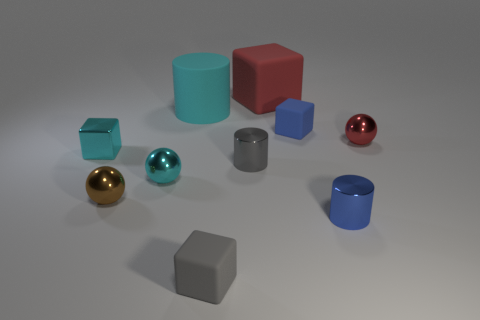Subtract all tiny metallic blocks. How many blocks are left? 3 Subtract all gray cylinders. How many cylinders are left? 2 Subtract 1 balls. How many balls are left? 2 Subtract all tiny purple balls. Subtract all tiny gray metal cylinders. How many objects are left? 9 Add 3 gray metallic cylinders. How many gray metallic cylinders are left? 4 Add 5 large gray metallic spheres. How many large gray metallic spheres exist? 5 Subtract 0 gray balls. How many objects are left? 10 Subtract all spheres. How many objects are left? 7 Subtract all gray cylinders. Subtract all yellow blocks. How many cylinders are left? 2 